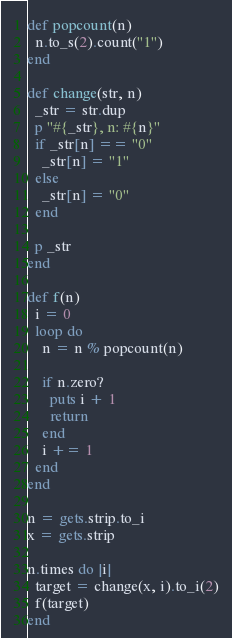<code> <loc_0><loc_0><loc_500><loc_500><_Ruby_>def popcount(n)
  n.to_s(2).count("1")
end

def change(str, n)
  _str = str.dup
  p "#{_str}, n: #{n}"
  if _str[n] == "0"
    _str[n] = "1"
  else
    _str[n] = "0"
  end
  
  p _str
end

def f(n)
  i = 0
  loop do
    n = n % popcount(n)
    
    if n.zero?
      puts i + 1
      return
    end
    i += 1
  end
end

n = gets.strip.to_i
x = gets.strip

n.times do |i|
  target = change(x, i).to_i(2)
  f(target)
end</code> 